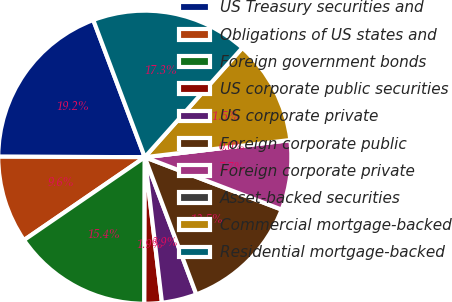Convert chart. <chart><loc_0><loc_0><loc_500><loc_500><pie_chart><fcel>US Treasury securities and<fcel>Obligations of US states and<fcel>Foreign government bonds<fcel>US corporate public securities<fcel>US corporate private<fcel>Foreign corporate public<fcel>Foreign corporate private<fcel>Asset-backed securities<fcel>Commercial mortgage-backed<fcel>Residential mortgage-backed<nl><fcel>19.23%<fcel>9.62%<fcel>15.38%<fcel>1.92%<fcel>3.85%<fcel>13.46%<fcel>7.69%<fcel>0.0%<fcel>11.54%<fcel>17.31%<nl></chart> 